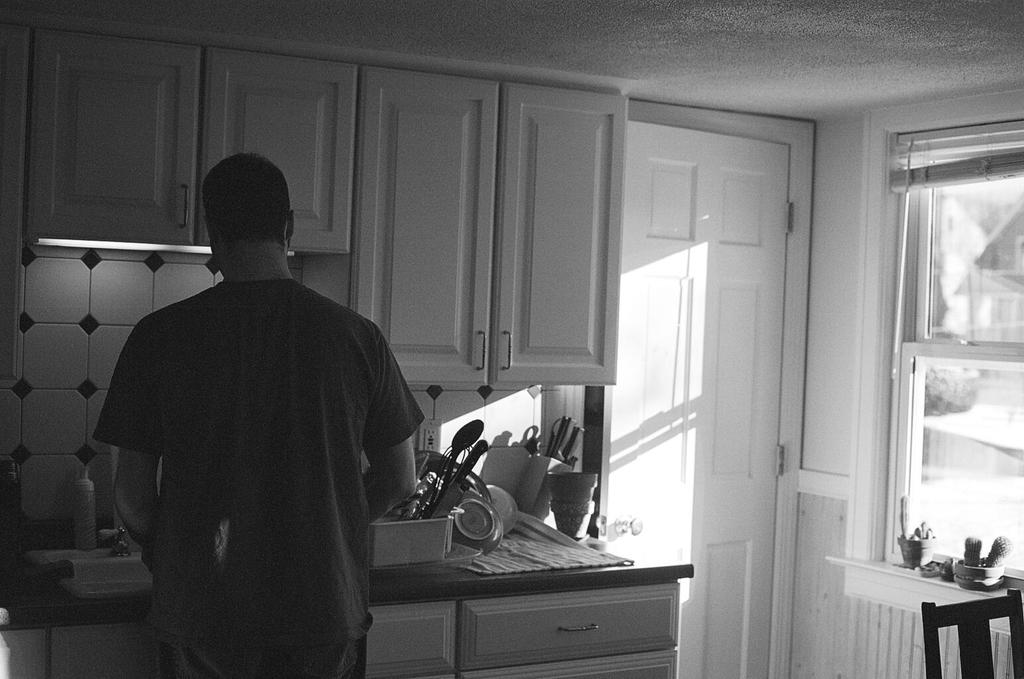What type of setting is shown in the image? The image depicts an inside view of a room. What furniture is present in the room? There is a chair in the room. Who is present in the room? There is a man in the room. What can be seen on the countertop in the room? There are items on the countertop. How is the image presented in terms of color? The photography is in black and white. What type of road can be seen outside the room in the image? There is no road visible in the image, as it depicts an inside view of a room. Are there any bears present in the room in the image? No, there are no bears present in the room in the image. 